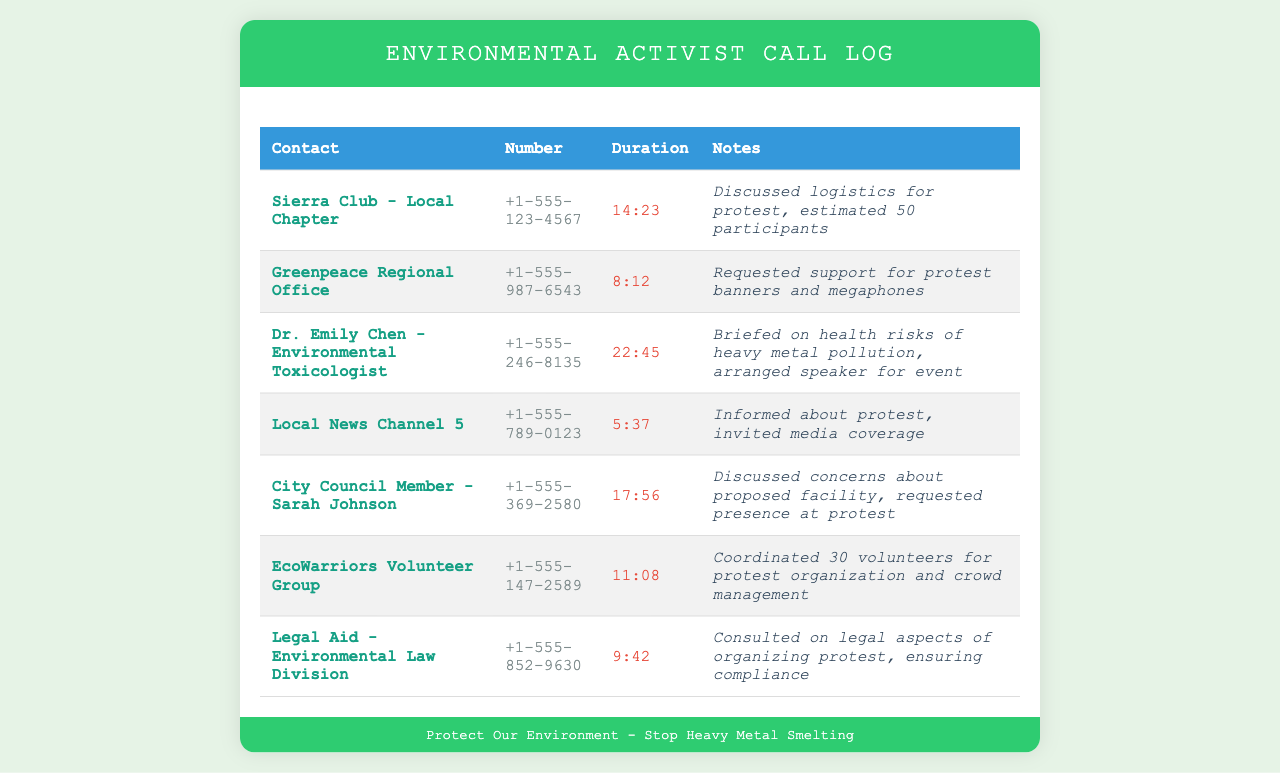what is the contact name for the local chapter? The contact name for the local chapter is listed as "Sierra Club - Local Chapter."
Answer: Sierra Club - Local Chapter how long was the call with Greenpeace Regional Office? The duration of the call with Greenpeace Regional Office is recorded as 8 minutes and 12 seconds.
Answer: 8:12 how many participants were estimated for the protest discussed with the Sierra Club? The document notes that the estimated number of participants for the protest is 50.
Answer: 50 participants who was consulted on legal aspects of organizing the protest? The contact for legal consultation is "Legal Aid - Environmental Law Division."
Answer: Legal Aid - Environmental Law Division which contact arranged a speaker for the event? The contact who arranged a speaker is Dr. Emily Chen, an Environmental Toxicologist.
Answer: Dr. Emily Chen how many volunteers were coordinated by EcoWarriors Volunteer Group? EcoWarriors Volunteer Group coordinated 30 volunteers for the protest organization and crowd management.
Answer: 30 volunteers what is the duration of the call with City Council Member Sarah Johnson? The duration of the call with City Council Member Sarah Johnson is reported to be 17 minutes and 56 seconds long.
Answer: 17:56 which organization was invited for media coverage of the protest? The organization invited for media coverage is the "Local News Channel 5."
Answer: Local News Channel 5 what was the topic of discussion during the call with Dr. Emily Chen? The discussion during the call with Dr. Emily Chen focused on health risks of heavy metal pollution.
Answer: health risks of heavy metal pollution 